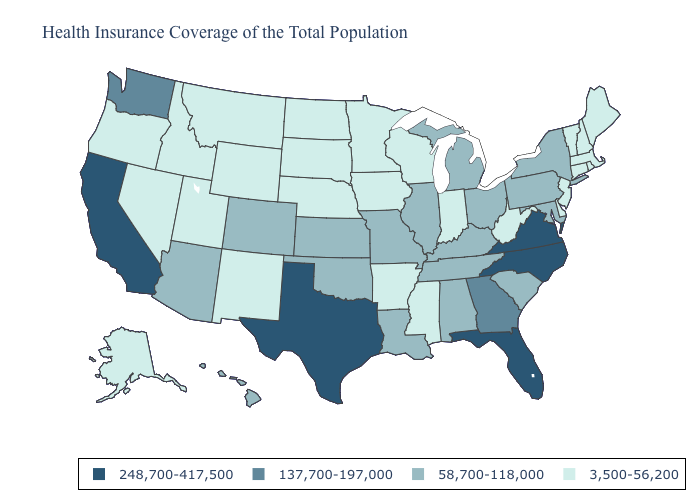Does Arkansas have a lower value than Connecticut?
Write a very short answer. No. What is the value of Alabama?
Give a very brief answer. 58,700-118,000. Among the states that border Mississippi , which have the lowest value?
Short answer required. Arkansas. What is the highest value in states that border Mississippi?
Write a very short answer. 58,700-118,000. Name the states that have a value in the range 137,700-197,000?
Keep it brief. Georgia, Washington. Which states have the lowest value in the USA?
Be succinct. Alaska, Arkansas, Connecticut, Delaware, Idaho, Indiana, Iowa, Maine, Massachusetts, Minnesota, Mississippi, Montana, Nebraska, Nevada, New Hampshire, New Jersey, New Mexico, North Dakota, Oregon, Rhode Island, South Dakota, Utah, Vermont, West Virginia, Wisconsin, Wyoming. What is the value of Montana?
Quick response, please. 3,500-56,200. What is the value of New York?
Write a very short answer. 58,700-118,000. Does the first symbol in the legend represent the smallest category?
Keep it brief. No. Name the states that have a value in the range 137,700-197,000?
Give a very brief answer. Georgia, Washington. Among the states that border New Jersey , does Delaware have the highest value?
Keep it brief. No. Does Pennsylvania have the highest value in the Northeast?
Write a very short answer. Yes. Which states hav the highest value in the West?
Answer briefly. California. What is the highest value in states that border Ohio?
Write a very short answer. 58,700-118,000. Which states have the lowest value in the USA?
Short answer required. Alaska, Arkansas, Connecticut, Delaware, Idaho, Indiana, Iowa, Maine, Massachusetts, Minnesota, Mississippi, Montana, Nebraska, Nevada, New Hampshire, New Jersey, New Mexico, North Dakota, Oregon, Rhode Island, South Dakota, Utah, Vermont, West Virginia, Wisconsin, Wyoming. 